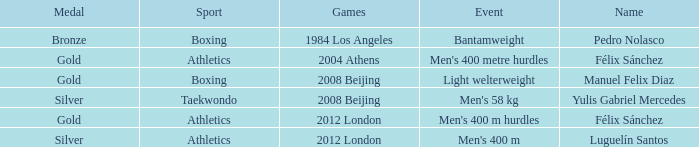Which Games had a Name of manuel felix diaz? 2008 Beijing. 